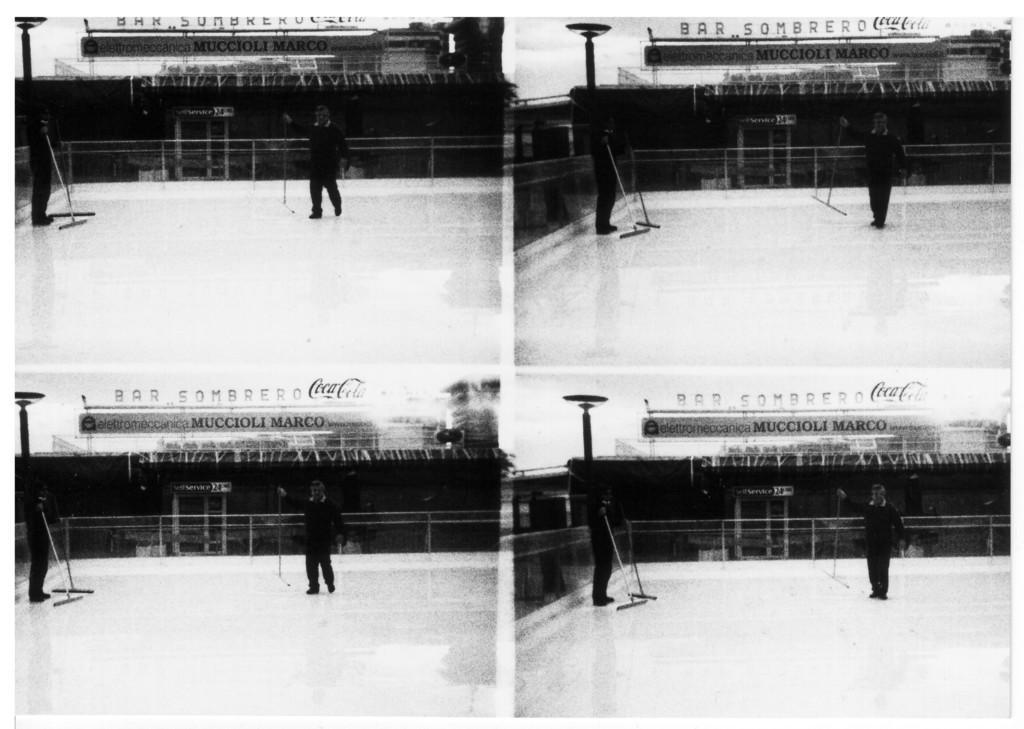Could you give a brief overview of what you see in this image? There is a collage image of four same pictures. In this image, we can see two persons wearing clothes and standing in front of the building. 